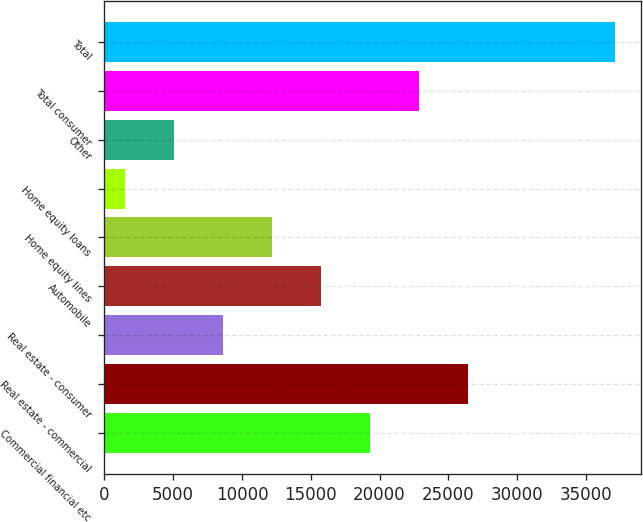Convert chart to OTSL. <chart><loc_0><loc_0><loc_500><loc_500><bar_chart><fcel>Commercial financial etc<fcel>Real estate - commercial<fcel>Real estate - consumer<fcel>Automobile<fcel>Home equity lines<fcel>Home equity loans<fcel>Other<fcel>Total consumer<fcel>Total<nl><fcel>19329<fcel>26449<fcel>8649<fcel>15769<fcel>12209<fcel>1529<fcel>5089<fcel>22889<fcel>37129<nl></chart> 